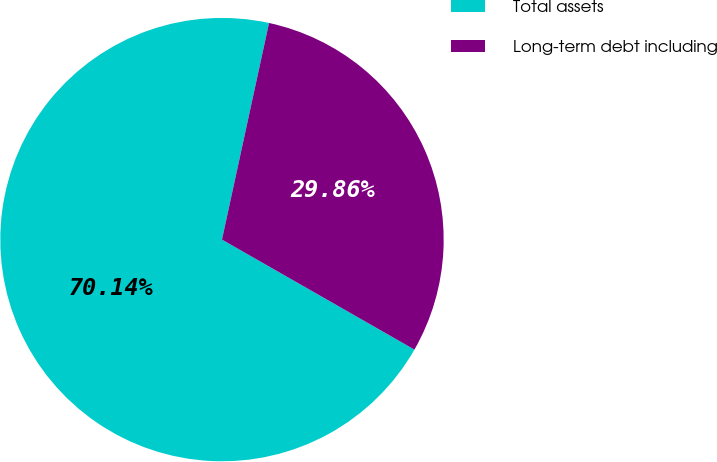Convert chart. <chart><loc_0><loc_0><loc_500><loc_500><pie_chart><fcel>Total assets<fcel>Long-term debt including<nl><fcel>70.14%<fcel>29.86%<nl></chart> 